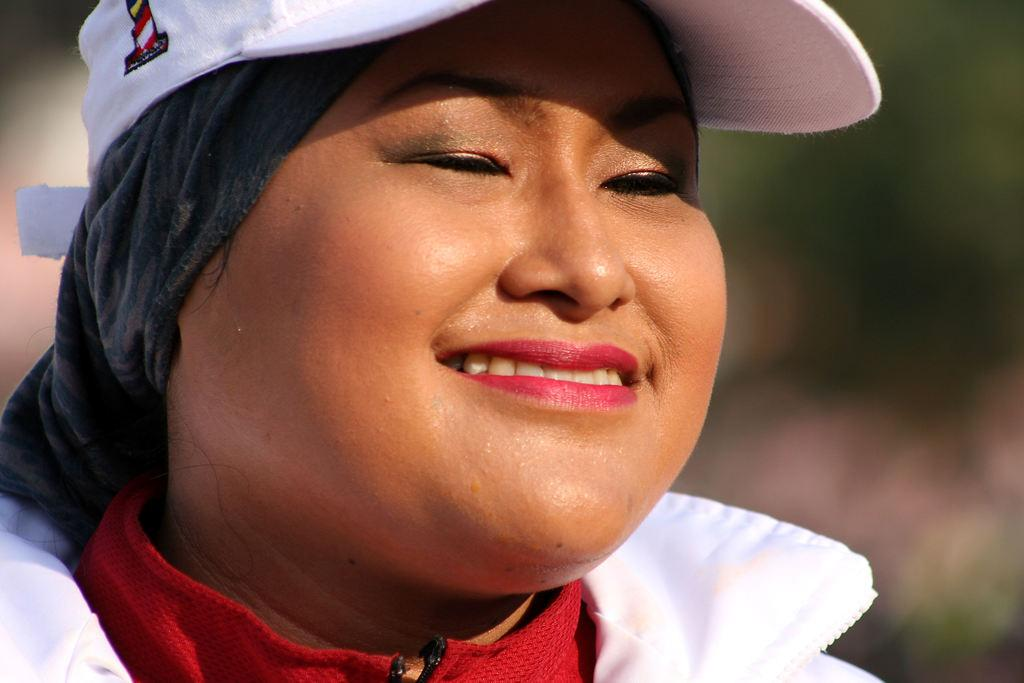Who or what is the main subject of the image? There is a person in the image. What is the person wearing? The person is wearing a white and red color dress and a white color cap. Can you describe the background of the image? The background of the image is blurred. How many dolls are sitting on the person's lap in the image? There are no dolls present in the image. What type of behavior is the person exhibiting in the image? The image does not provide information about the person's behavior. 